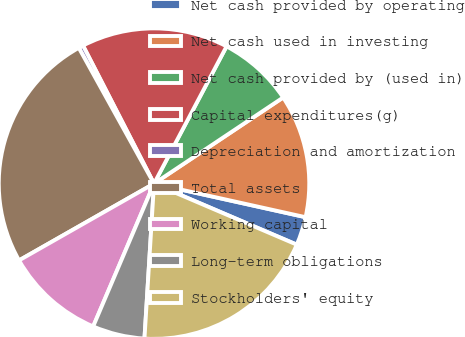Convert chart to OTSL. <chart><loc_0><loc_0><loc_500><loc_500><pie_chart><fcel>Net cash provided by operating<fcel>Net cash used in investing<fcel>Net cash provided by (used in)<fcel>Capital expenditures(g)<fcel>Depreciation and amortization<fcel>Total assets<fcel>Working capital<fcel>Long-term obligations<fcel>Stockholders' equity<nl><fcel>2.96%<fcel>12.83%<fcel>7.9%<fcel>15.3%<fcel>0.49%<fcel>25.18%<fcel>10.36%<fcel>5.43%<fcel>19.55%<nl></chart> 